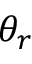<formula> <loc_0><loc_0><loc_500><loc_500>\theta _ { r }</formula> 